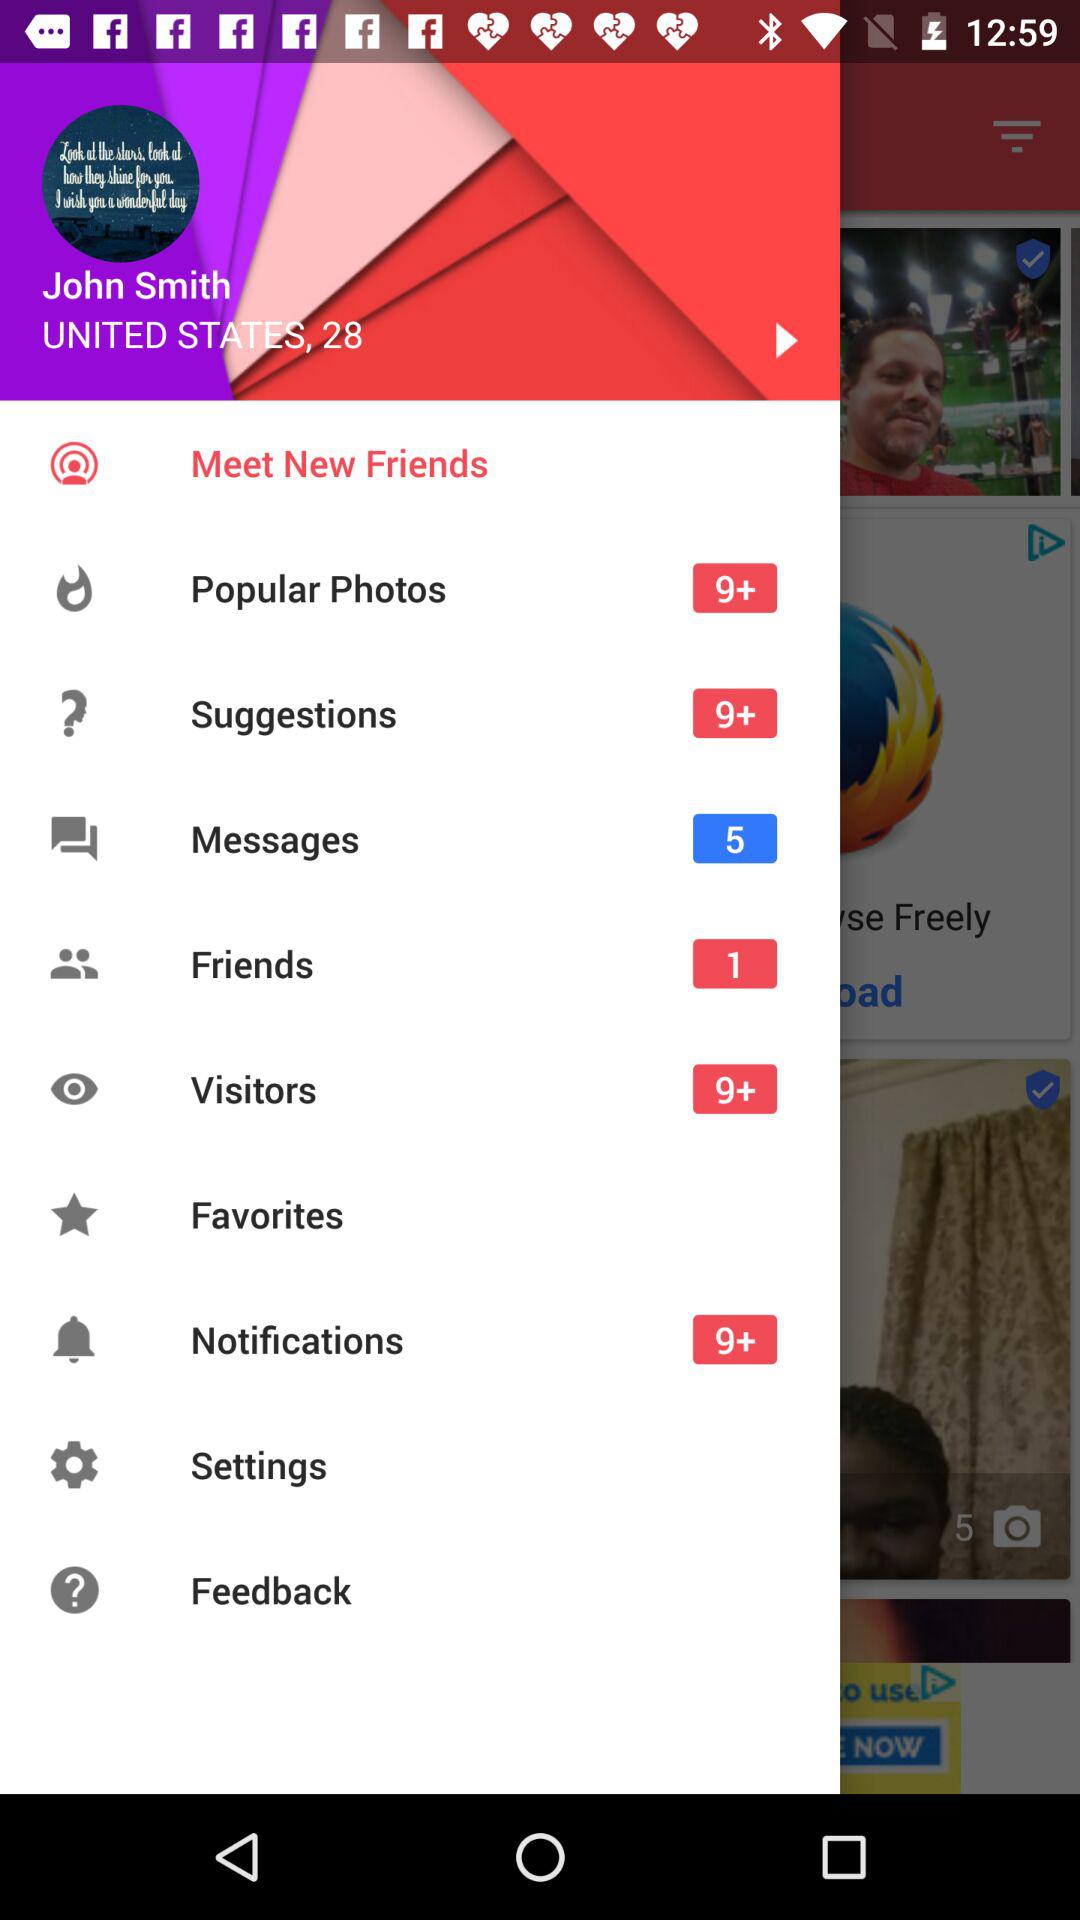What's the user name? The user name is John Smith. 